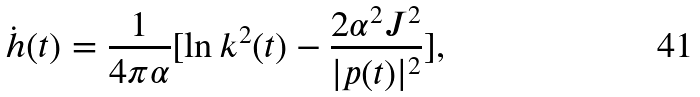Convert formula to latex. <formula><loc_0><loc_0><loc_500><loc_500>\dot { h } ( t ) = \frac { 1 } { 4 \pi \alpha } [ \ln k ^ { 2 } ( t ) - \frac { 2 \alpha ^ { 2 } J ^ { 2 } } { | p ( t ) | ^ { 2 } } ] ,</formula> 